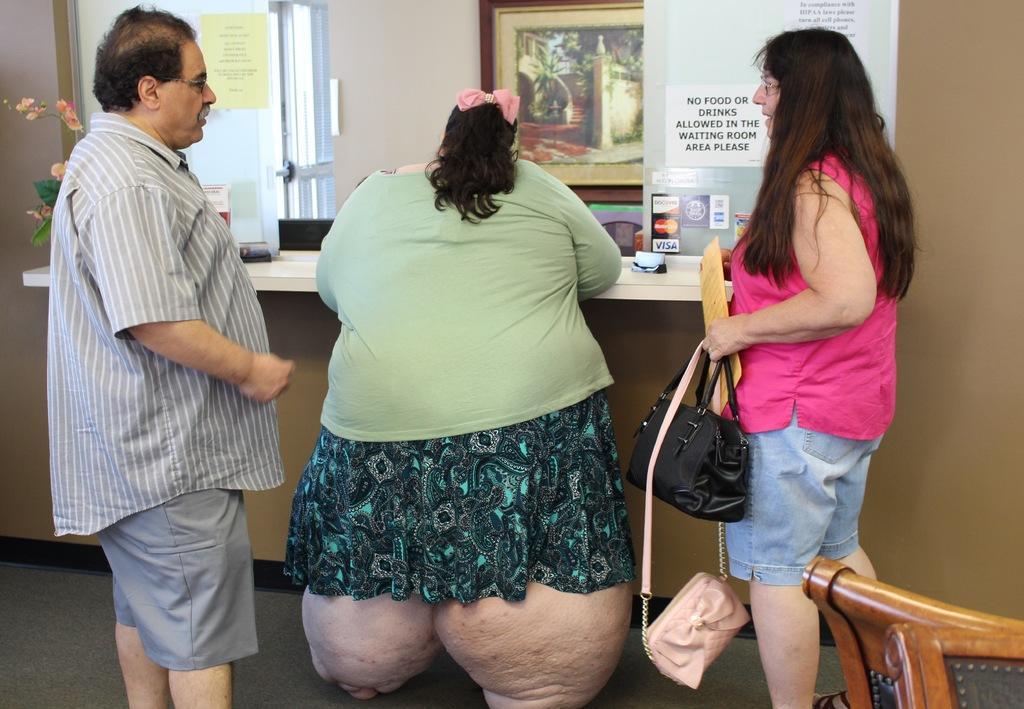Can you describe this image briefly? In the picture we can find three people, one man and two women standing near the table. In the background we can find the door, photo, paper stick on it. On the table we can find a plant, flowers. One woman is holding a handbag and another woman is leaning on the table and the man is wearing the shirt. 